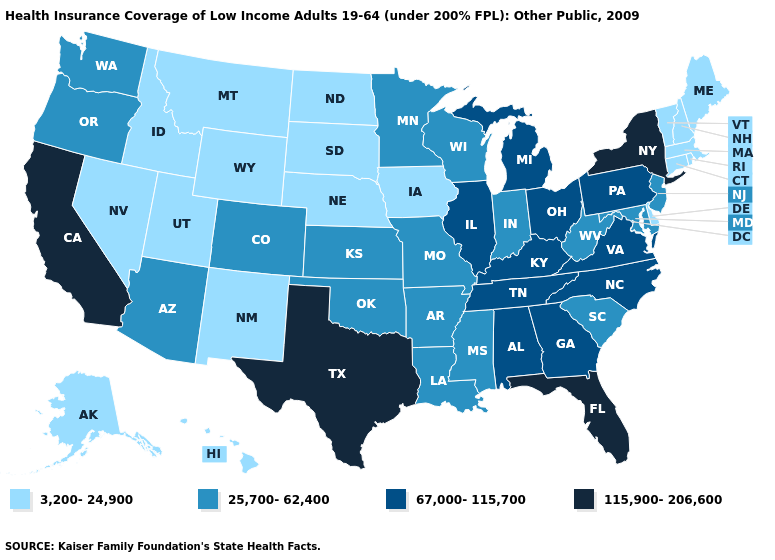Does Arizona have a lower value than Pennsylvania?
Answer briefly. Yes. Among the states that border California , does Nevada have the highest value?
Answer briefly. No. What is the lowest value in the MidWest?
Answer briefly. 3,200-24,900. What is the highest value in states that border Missouri?
Quick response, please. 67,000-115,700. What is the value of Arkansas?
Keep it brief. 25,700-62,400. Name the states that have a value in the range 67,000-115,700?
Give a very brief answer. Alabama, Georgia, Illinois, Kentucky, Michigan, North Carolina, Ohio, Pennsylvania, Tennessee, Virginia. Which states have the highest value in the USA?
Answer briefly. California, Florida, New York, Texas. What is the value of South Dakota?
Write a very short answer. 3,200-24,900. Among the states that border West Virginia , does Maryland have the highest value?
Concise answer only. No. Does Michigan have a higher value than Oklahoma?
Answer briefly. Yes. Which states have the lowest value in the South?
Write a very short answer. Delaware. What is the value of New York?
Quick response, please. 115,900-206,600. Does Florida have the same value as Hawaii?
Short answer required. No. What is the value of Alaska?
Give a very brief answer. 3,200-24,900. 